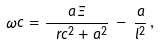Convert formula to latex. <formula><loc_0><loc_0><loc_500><loc_500>\omega c = \frac { a \, \Xi } { \ r c ^ { 2 } + a ^ { 2 } } \, - \, \frac { a } { l ^ { 2 } } \, ,</formula> 